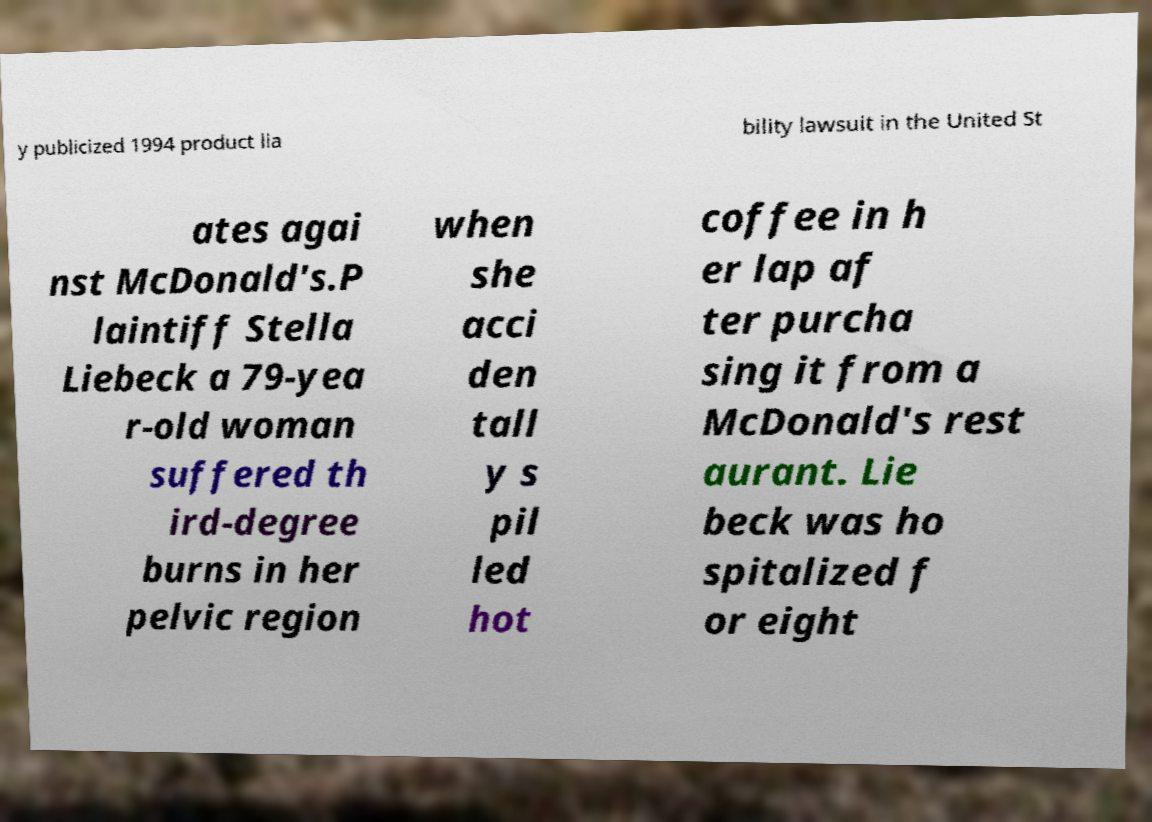Please read and relay the text visible in this image. What does it say? y publicized 1994 product lia bility lawsuit in the United St ates agai nst McDonald's.P laintiff Stella Liebeck a 79-yea r-old woman suffered th ird-degree burns in her pelvic region when she acci den tall y s pil led hot coffee in h er lap af ter purcha sing it from a McDonald's rest aurant. Lie beck was ho spitalized f or eight 